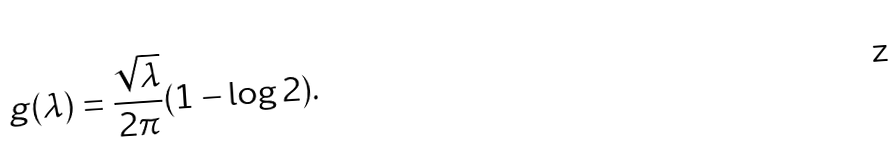<formula> <loc_0><loc_0><loc_500><loc_500>g ( \lambda ) = \frac { \sqrt { \lambda } } { 2 \pi } ( 1 - \log 2 ) .</formula> 